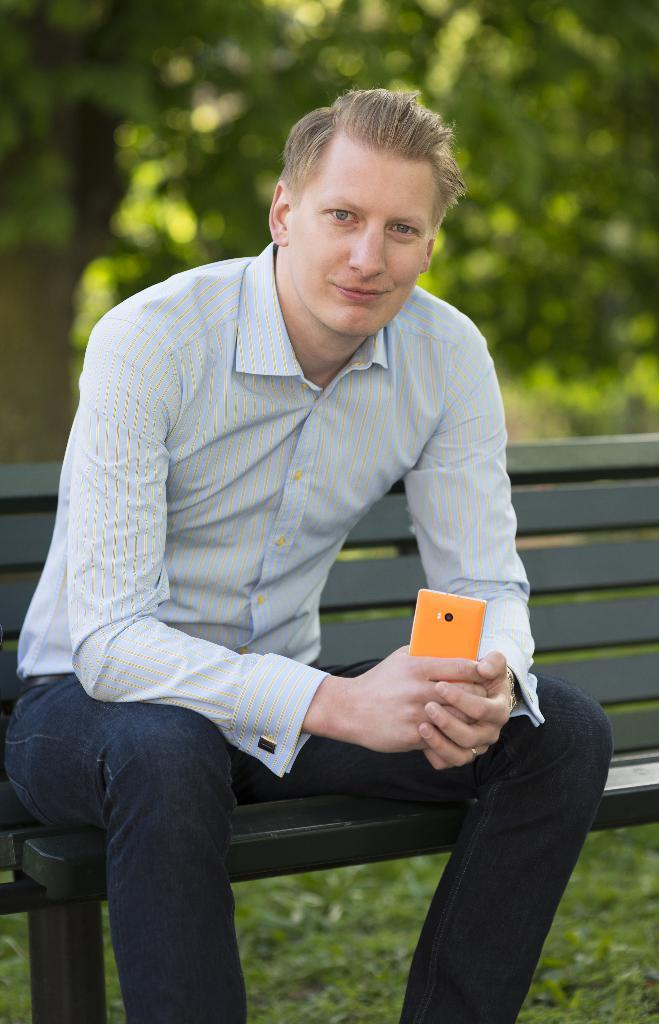Who is present in the image? There is a man in the image. What is the man doing in the image? The man is sitting on a bench. What object is the man holding in the image? The man is holding a mobile phone. What type of natural environment is visible in the image? There is grass visible in the image. What can be seen in the background of the image? There are trees in the background of the image. What type of window can be seen in the image? There is no window present in the image. How is the distribution of the grass in the image? The question about the distribution of the grass is not relevant to the image, as the focus should be on the description of the visible elements. 